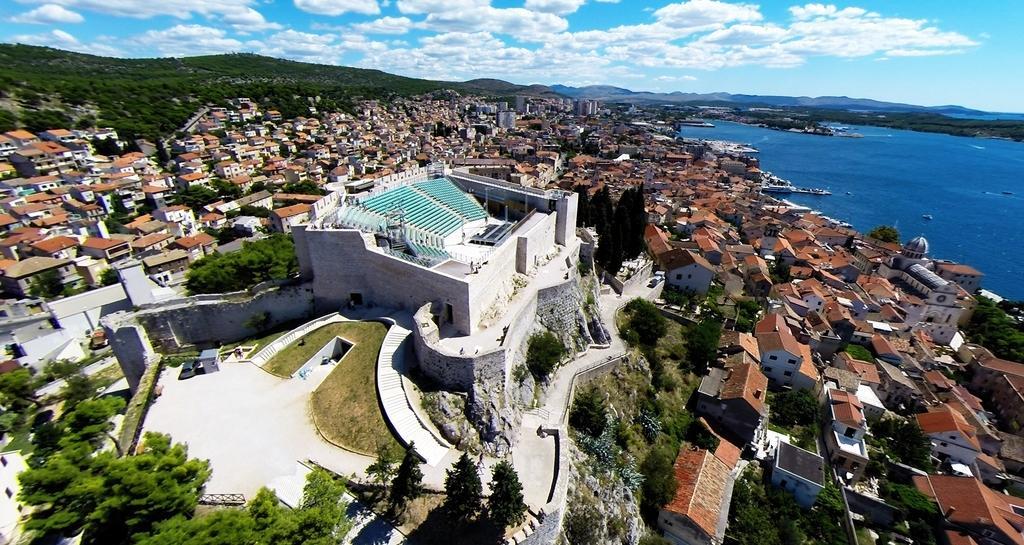Could you give a brief overview of what you see in this image? In this image, I can see the view of a city with the buildings, houses, trees and hills. On the right side of the image, there is water. In the background, I can see the sky. 